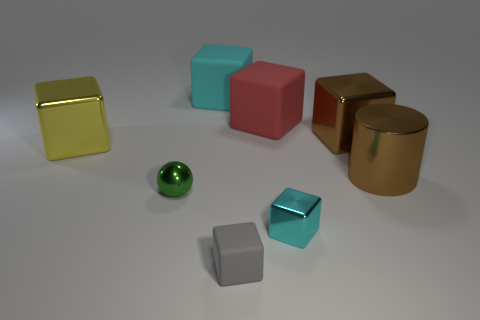Is there a green shiny object that has the same shape as the tiny gray matte thing?
Keep it short and to the point. No. There is a red matte thing that is the same size as the cylinder; what shape is it?
Offer a terse response. Cube. What is the shape of the brown metallic thing behind the brown metallic cylinder that is behind the shiny ball in front of the big cyan block?
Ensure brevity in your answer.  Cube. Is the shape of the gray thing the same as the cyan thing that is right of the tiny gray matte thing?
Your answer should be compact. Yes. What number of large objects are either cubes or rubber cubes?
Offer a terse response. 4. Is there a yellow shiny object that has the same size as the brown metallic cylinder?
Offer a terse response. Yes. The tiny thing that is right of the small block on the left side of the cyan object that is in front of the large brown cylinder is what color?
Ensure brevity in your answer.  Cyan. Does the tiny gray thing have the same material as the cyan thing that is behind the big yellow metallic cube?
Ensure brevity in your answer.  Yes. There is a cyan metallic object that is the same shape as the small gray thing; what size is it?
Your answer should be compact. Small. Is the number of green metal balls that are behind the tiny green metallic object the same as the number of metal blocks that are behind the brown shiny cylinder?
Provide a succinct answer. No. 